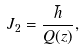<formula> <loc_0><loc_0><loc_500><loc_500>J _ { 2 } = \frac { \bar { h } } { Q ( z ) } ,</formula> 